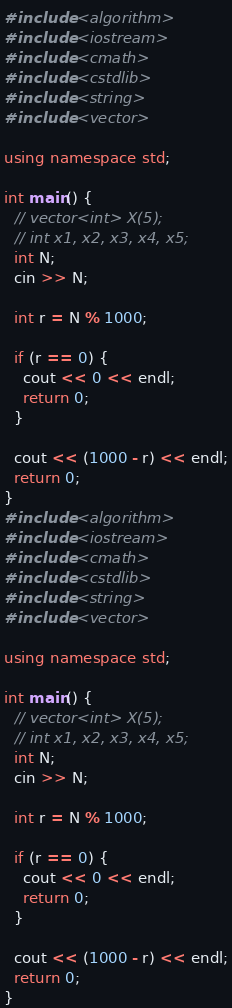Convert code to text. <code><loc_0><loc_0><loc_500><loc_500><_C++_>#include <algorithm>
#include <iostream>
#include <cmath>
#include <cstdlib>
#include <string>
#include <vector>

using namespace std;

int main() {
  // vector<int> X(5);
  // int x1, x2, x3, x4, x5;
  int N;
  cin >> N;

  int r = N % 1000;

  if (r == 0) {
    cout << 0 << endl;
    return 0;
  }

  cout << (1000 - r) << endl;
  return 0;
}
#include <algorithm>
#include <iostream>
#include <cmath>
#include <cstdlib>
#include <string>
#include <vector>

using namespace std;

int main() {
  // vector<int> X(5);
  // int x1, x2, x3, x4, x5;
  int N;
  cin >> N;

  int r = N % 1000;

  if (r == 0) {
    cout << 0 << endl;
    return 0;
  }

  cout << (1000 - r) << endl;
  return 0;
}
</code> 